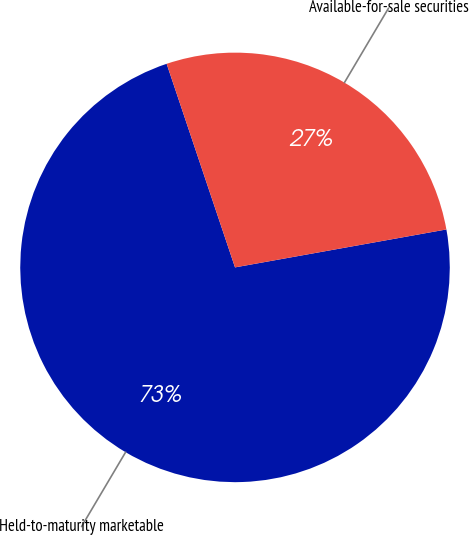Convert chart to OTSL. <chart><loc_0><loc_0><loc_500><loc_500><pie_chart><fcel>Held-to-maturity marketable<fcel>Available-for-sale securities<nl><fcel>72.67%<fcel>27.33%<nl></chart> 